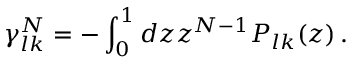Convert formula to latex. <formula><loc_0><loc_0><loc_500><loc_500>\gamma _ { l k } ^ { N } = - \int _ { 0 } ^ { 1 } d z z ^ { N - 1 } P _ { l k } ( z ) \, .</formula> 